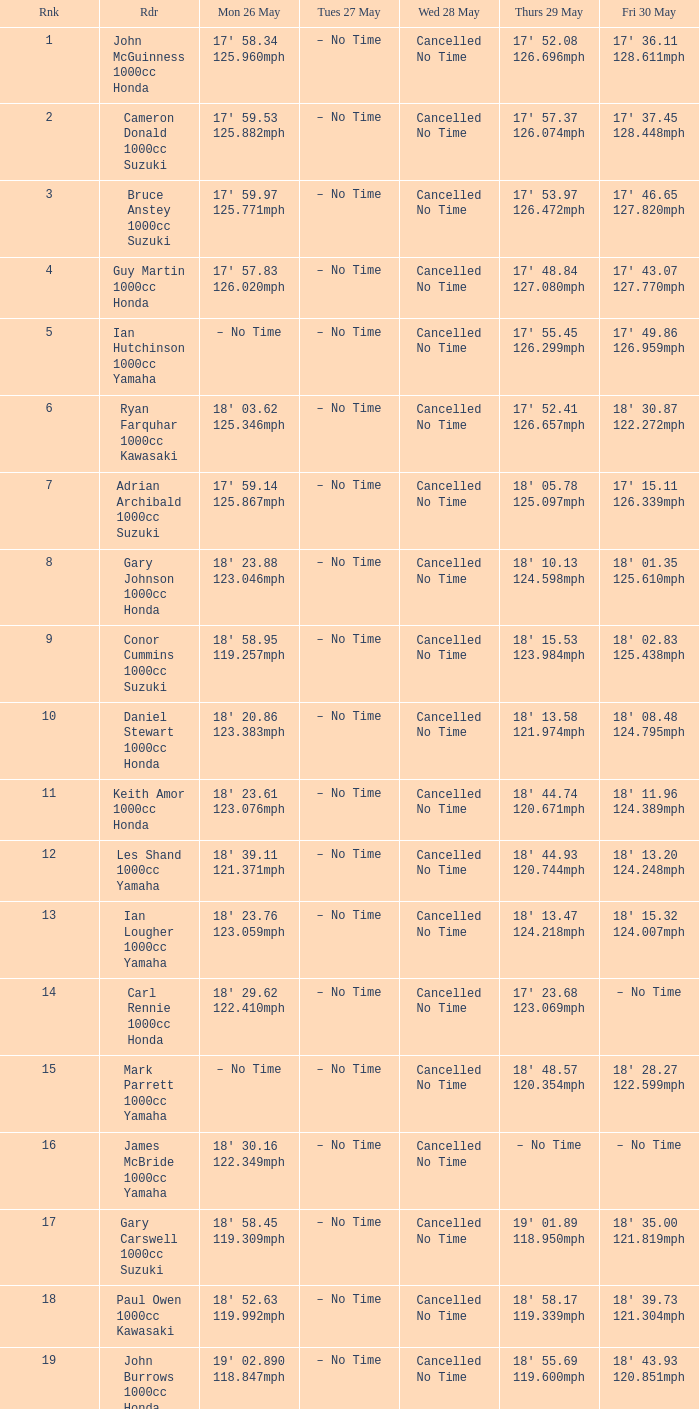27 12 – No Time. 